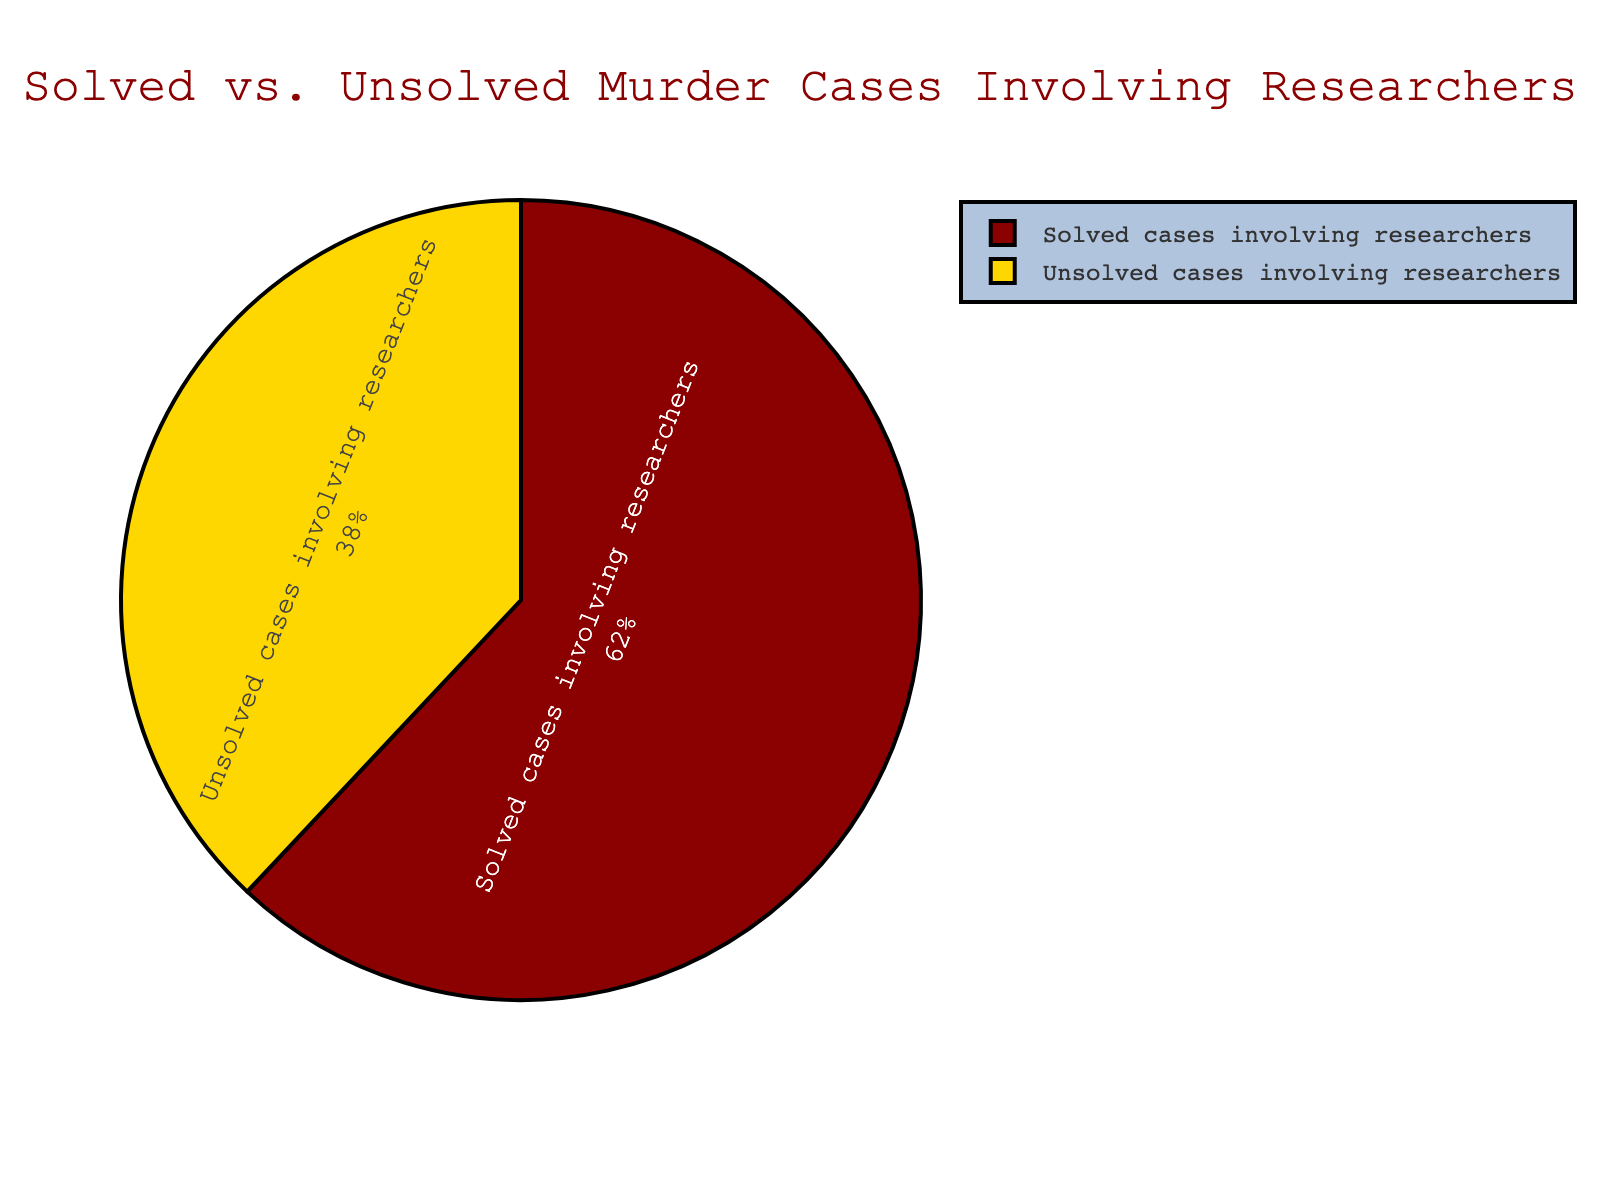What percentage of murder cases involving researchers remain unsolved? The pie chart shows the Percentage of solved vs. unsolved murder cases. The segment representing unsolved cases involving researchers is 38%.
Answer: 38% How much higher is the percentage of solved cases compared to unsolved cases? The pie chart shows that solved cases represent 62% and unsolved cases represent 38%. To find the difference, subtract the percentage of unsolved cases from solved cases: 62% - 38% = 24%.
Answer: 24% Which category has a higher percentage of cases, solved or unsolved? The pie chart has two categories, solved and unsolved. The segment for solved cases is 62%, which is greater than the 38% for unsolved cases.
Answer: Solved What is the combined percentage of all murder cases involving researchers? A pie chart represents a complete set of data with percentages totaling 100%. Adding the percentages of solved and unsolved cases: 62% + 38% = 100%.
Answer: 100% What is the primary color used to represent unsolved cases in the pie chart? By observing the pie chart, the segment representing unsolved cases is colored in gold.
Answer: Gold If the total number of murder cases involving researchers is 100, how many of those are solved? The pie chart indicates that 62% of the cases are solved. Multiplying 62% by 100 gives 62 solved cases: 100 * 0.62 = 62.
Answer: 62 What is the ratio of solved to unsolved murder cases involving researchers? To find the ratio of solved to unsolved cases, divide the percentage of solved cases by the percentage of unsolved cases: 62% / 38%. Simplifying this ratio gives 62:38 or 31:19.
Answer: 31:19 Is the difference between the percentage of solved and unsolved cases greater than 20%? The difference between the solved (62%) and unsolved (38%) cases is calculated as 62% - 38% = 24%. Since 24% > 20%, the difference is indeed greater than 20%.
Answer: Yes If 10 new cases are recorded, maintaining the same solved percentage, how many additional unsolved cases would there be? 62% of the new 10 cases would be solved, implying 38% remain unsolved. Thus, 38% of 10 cases is 10 * 0.38 = 3.8 or approximately 4 unsolved cases.
Answer: 4 What percentage of total cases does the category with fewer cases represent? The category with fewer cases in the pie chart is the unsolved cases, which represent 38% of the total cases.
Answer: 38% 